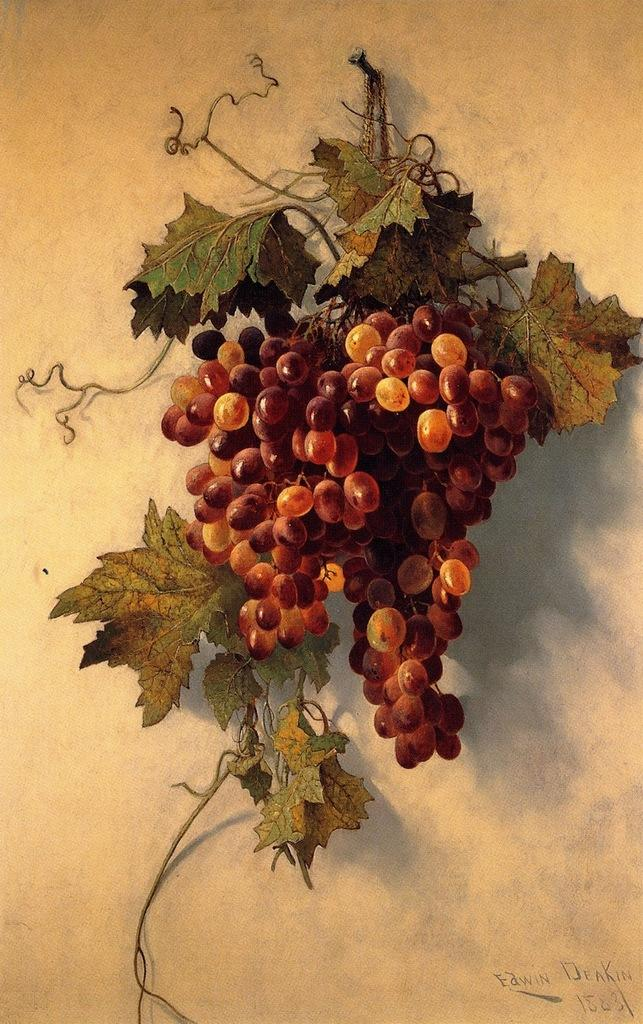What is depicted in the painting in the image? The painting contains a depiction of grapes. What other elements are included in the painting? The painting includes leaves and stems. What color is the background of the painting? The background of the painting is white. Where can text be found in the image? There is text in the bottom right corner of the image. How many cents are visible in the image? There are no cents present in the image; it features a painting of grapes with a white background and text in the bottom right corner. What type of patch is sewn onto the grapes in the image? There is no patch present on the grapes in the image; it is a painting with leaves, stems, and text in the bottom right corner. 